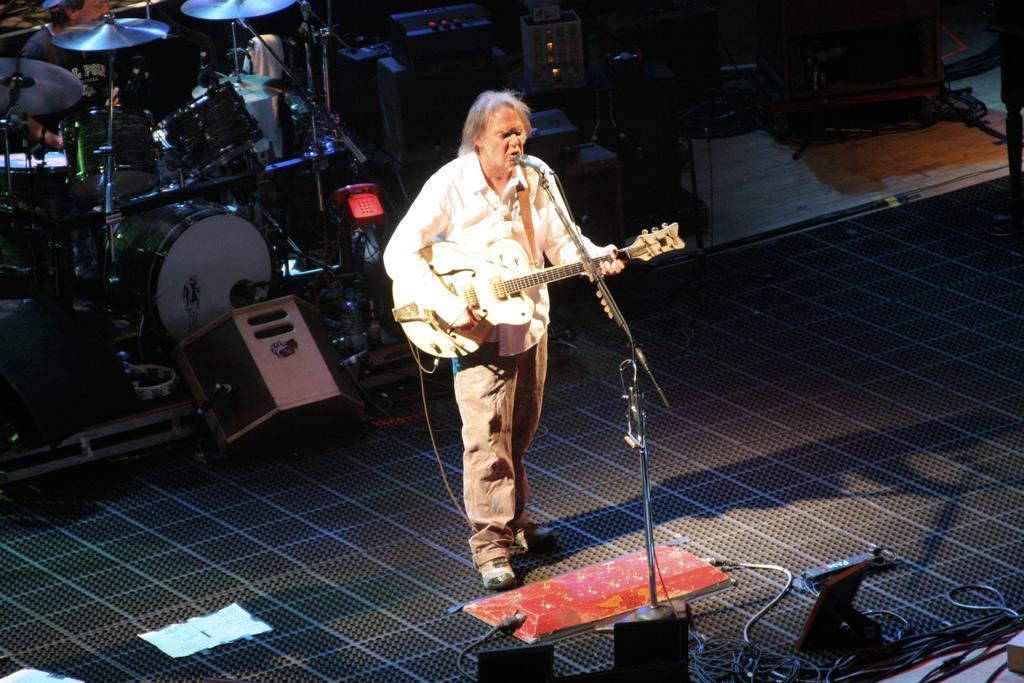Could you give a brief overview of what you see in this image? There is a man standing on a stage playing a guitar and singing and a microphone behind him there are so many musical instruments and a telephone. 